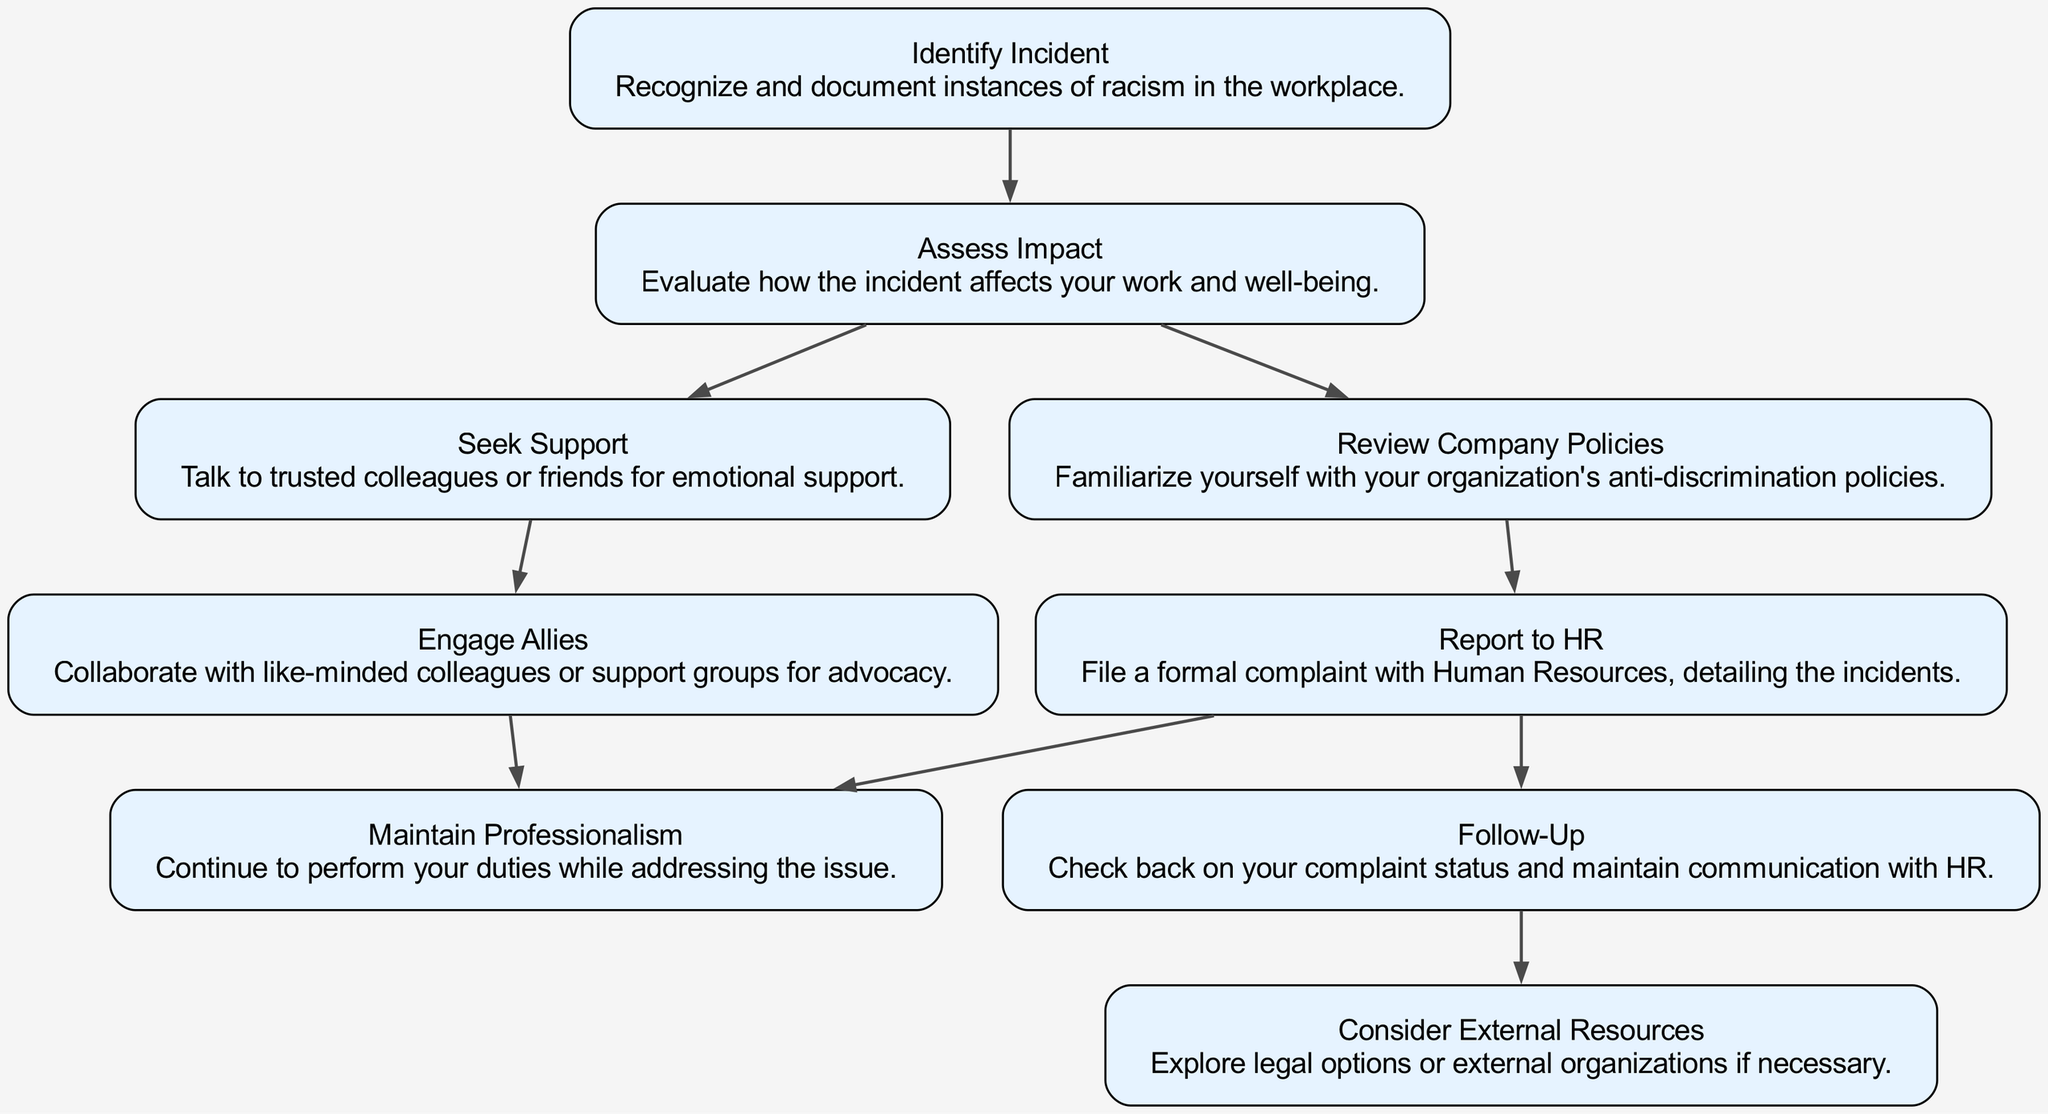What is the first step in the flow chart? The first step in the flow chart is to identify the incident. This is indicated by the first node labeled "Identify Incident."
Answer: Identify Incident How many total nodes are there in the diagram? The diagram contains a total of nine nodes, as seen in the data provided with the "nodes" key containing nine entries.
Answer: 9 What follows after assessing the impact of the incident? After assessing the impact, the next steps available are to seek support or review company policies, both stemming directly from the "Assess Impact" node.
Answer: Seek Support or Review Company Policies What action can be taken after reporting to HR? After reporting to HR, the next action prescribed in the flow chart is to follow-up on the complaint status and maintain communication with HR. This is indicated by the directed edge from "Report to HR" to "Follow-Up."
Answer: Follow-Up Which two nodes are connected after seeking support? After seeking support, the flow chart connects to the "Engage Allies" node, indicating a relationship between these two actions.
Answer: Engage Allies What is the last option if the internal complaint resolution is insufficient? If internal complaint resolution does not suffice, the last option indicated in the flow chart is "Consider External Resources," suggesting further external support or legal options.
Answer: Consider External Resources What does the node "Maintain Professionalism" emphasize? The "Maintain Professionalism" node emphasizes the importance of continuing to perform job duties while also addressing racism in the workplace, indicating the need for professionalism amidst challenges.
Answer: Continue to perform duties Which node leads to both "Follow-Up" and "Maintain Professionalism"? The node that leads to both "Follow-Up" and "Maintain Professionalism" is "Report to HR," which indicates that after filing a complaint, both actions are necessary.
Answer: Report to HR What should be evaluated after identifying an incident of racism? After identifying an incident of racism, it is crucial to assess its impact, as indicated by the flow direction from "Identify Incident" to "Assess Impact."
Answer: Assess Impact 